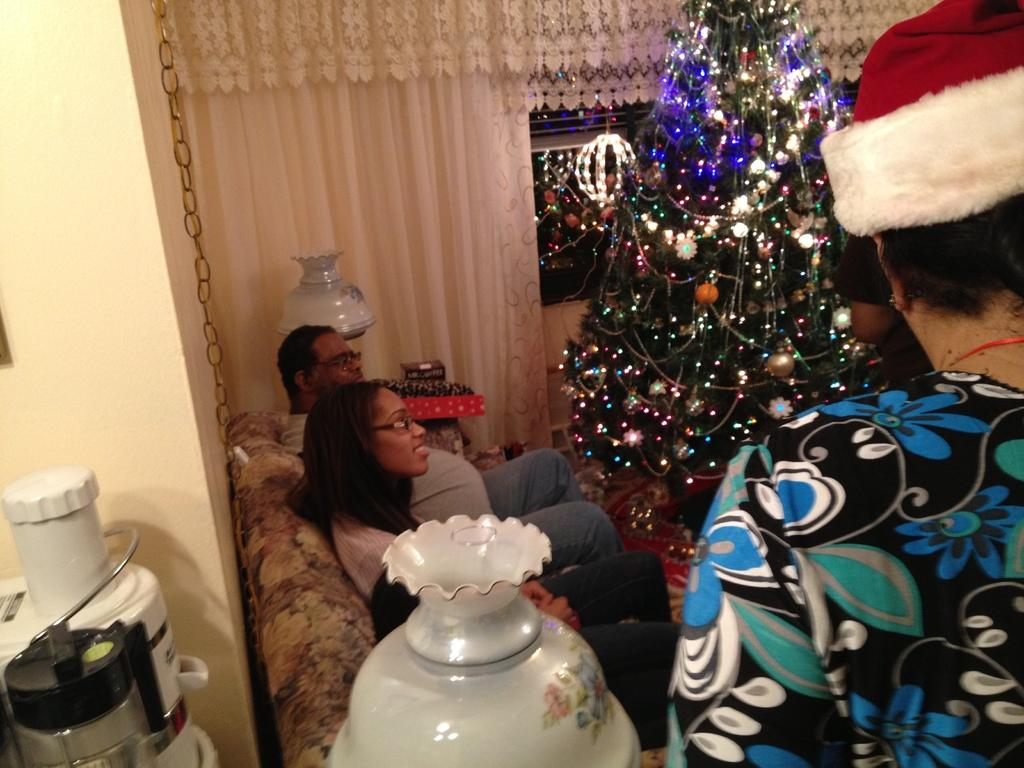What are the people in the image doing? There are persons sitting on the sofa in the image. Can you describe the woman in the image? There is a woman standing in the image. What can be seen in the background of the image? There is a Christmas tree, a curtain, food processors, and vases in the background. How many dogs are playing basketball in the image? There are no dogs or basketballs present in the image. 